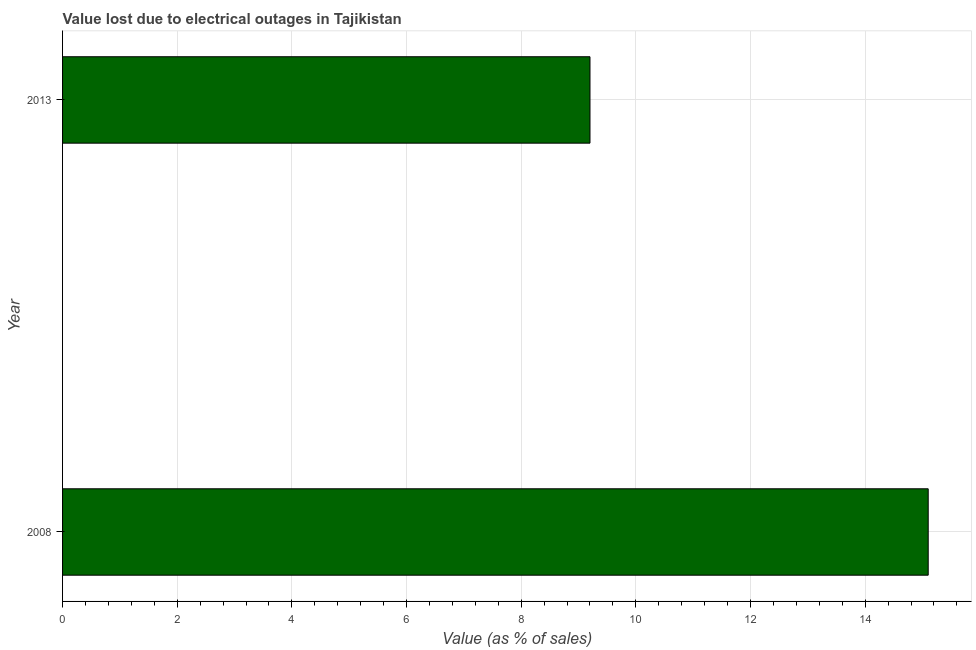Does the graph contain any zero values?
Provide a short and direct response. No. Does the graph contain grids?
Make the answer very short. Yes. What is the title of the graph?
Give a very brief answer. Value lost due to electrical outages in Tajikistan. What is the label or title of the X-axis?
Your answer should be very brief. Value (as % of sales). Across all years, what is the maximum value lost due to electrical outages?
Offer a very short reply. 15.1. Across all years, what is the minimum value lost due to electrical outages?
Provide a short and direct response. 9.2. In which year was the value lost due to electrical outages maximum?
Your answer should be compact. 2008. In which year was the value lost due to electrical outages minimum?
Provide a succinct answer. 2013. What is the sum of the value lost due to electrical outages?
Your response must be concise. 24.3. What is the average value lost due to electrical outages per year?
Your answer should be very brief. 12.15. What is the median value lost due to electrical outages?
Offer a terse response. 12.15. Do a majority of the years between 2008 and 2013 (inclusive) have value lost due to electrical outages greater than 2.4 %?
Your response must be concise. Yes. What is the ratio of the value lost due to electrical outages in 2008 to that in 2013?
Provide a short and direct response. 1.64. In how many years, is the value lost due to electrical outages greater than the average value lost due to electrical outages taken over all years?
Your answer should be very brief. 1. How many bars are there?
Your answer should be compact. 2. How many years are there in the graph?
Make the answer very short. 2. What is the difference between two consecutive major ticks on the X-axis?
Provide a succinct answer. 2. Are the values on the major ticks of X-axis written in scientific E-notation?
Your answer should be very brief. No. What is the Value (as % of sales) in 2013?
Give a very brief answer. 9.2. What is the difference between the Value (as % of sales) in 2008 and 2013?
Offer a very short reply. 5.9. What is the ratio of the Value (as % of sales) in 2008 to that in 2013?
Ensure brevity in your answer.  1.64. 